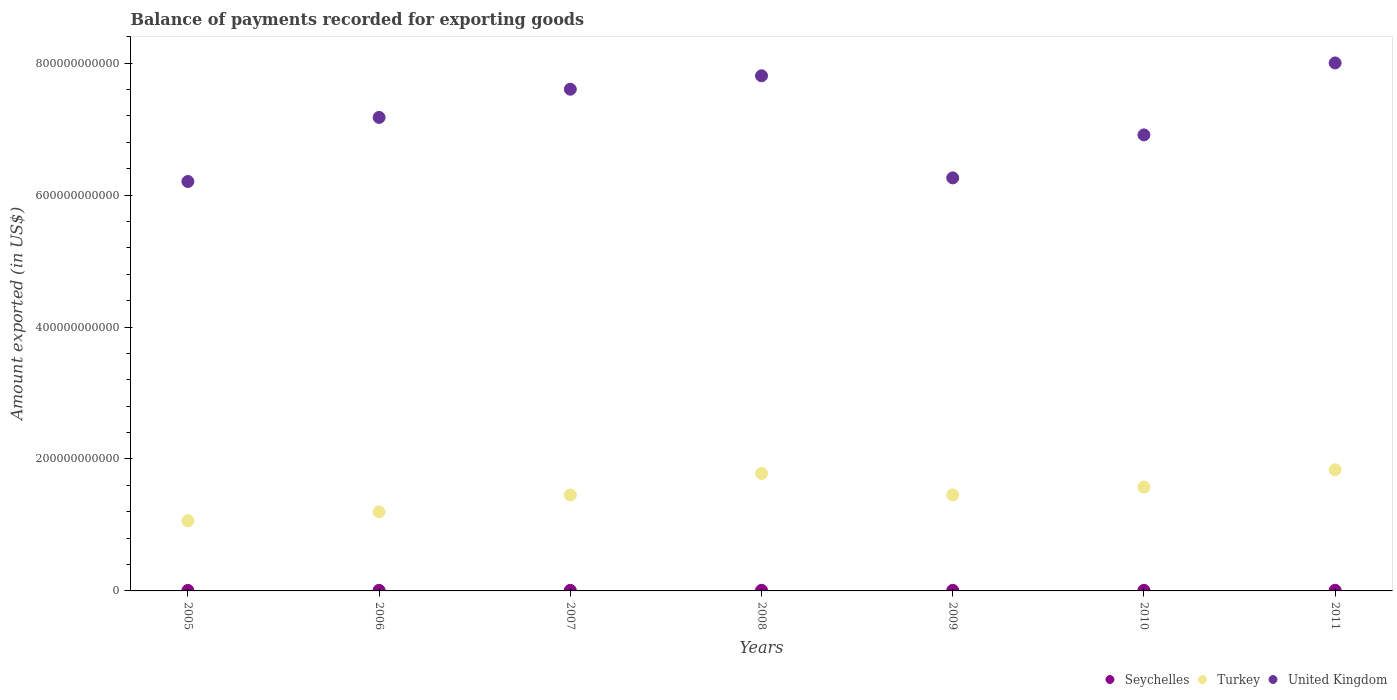Is the number of dotlines equal to the number of legend labels?
Ensure brevity in your answer.  Yes. What is the amount exported in Seychelles in 2011?
Keep it short and to the point. 9.42e+08. Across all years, what is the maximum amount exported in United Kingdom?
Provide a succinct answer. 8.00e+11. Across all years, what is the minimum amount exported in United Kingdom?
Your response must be concise. 6.21e+11. What is the total amount exported in Seychelles in the graph?
Ensure brevity in your answer.  5.96e+09. What is the difference between the amount exported in Turkey in 2005 and that in 2010?
Offer a very short reply. -5.11e+1. What is the difference between the amount exported in United Kingdom in 2009 and the amount exported in Seychelles in 2007?
Your answer should be compact. 6.25e+11. What is the average amount exported in Seychelles per year?
Ensure brevity in your answer.  8.51e+08. In the year 2011, what is the difference between the amount exported in Seychelles and amount exported in Turkey?
Your answer should be very brief. -1.83e+11. In how many years, is the amount exported in Seychelles greater than 760000000000 US$?
Your answer should be compact. 0. What is the ratio of the amount exported in United Kingdom in 2006 to that in 2011?
Offer a very short reply. 0.9. Is the difference between the amount exported in Seychelles in 2006 and 2010 greater than the difference between the amount exported in Turkey in 2006 and 2010?
Offer a terse response. Yes. What is the difference between the highest and the second highest amount exported in United Kingdom?
Give a very brief answer. 1.95e+1. What is the difference between the highest and the lowest amount exported in Seychelles?
Offer a very short reply. 2.23e+08. Is the sum of the amount exported in United Kingdom in 2005 and 2009 greater than the maximum amount exported in Turkey across all years?
Offer a terse response. Yes. Is it the case that in every year, the sum of the amount exported in United Kingdom and amount exported in Seychelles  is greater than the amount exported in Turkey?
Your answer should be very brief. Yes. Is the amount exported in Turkey strictly greater than the amount exported in United Kingdom over the years?
Offer a very short reply. No. How many years are there in the graph?
Make the answer very short. 7. What is the difference between two consecutive major ticks on the Y-axis?
Provide a short and direct response. 2.00e+11. Are the values on the major ticks of Y-axis written in scientific E-notation?
Offer a very short reply. No. Does the graph contain any zero values?
Offer a terse response. No. Does the graph contain grids?
Your answer should be compact. No. How are the legend labels stacked?
Ensure brevity in your answer.  Horizontal. What is the title of the graph?
Offer a terse response. Balance of payments recorded for exporting goods. Does "Arab World" appear as one of the legend labels in the graph?
Your response must be concise. No. What is the label or title of the Y-axis?
Offer a very short reply. Amount exported (in US$). What is the Amount exported (in US$) of Seychelles in 2005?
Make the answer very short. 7.20e+08. What is the Amount exported (in US$) of Turkey in 2005?
Ensure brevity in your answer.  1.06e+11. What is the Amount exported (in US$) in United Kingdom in 2005?
Give a very brief answer. 6.21e+11. What is the Amount exported (in US$) of Seychelles in 2006?
Offer a terse response. 8.50e+08. What is the Amount exported (in US$) in Turkey in 2006?
Provide a short and direct response. 1.20e+11. What is the Amount exported (in US$) in United Kingdom in 2006?
Provide a short and direct response. 7.18e+11. What is the Amount exported (in US$) of Seychelles in 2007?
Give a very brief answer. 8.54e+08. What is the Amount exported (in US$) in Turkey in 2007?
Give a very brief answer. 1.45e+11. What is the Amount exported (in US$) in United Kingdom in 2007?
Make the answer very short. 7.61e+11. What is the Amount exported (in US$) in Seychelles in 2008?
Give a very brief answer. 9.02e+08. What is the Amount exported (in US$) in Turkey in 2008?
Offer a very short reply. 1.78e+11. What is the Amount exported (in US$) in United Kingdom in 2008?
Ensure brevity in your answer.  7.81e+11. What is the Amount exported (in US$) in Seychelles in 2009?
Your response must be concise. 8.50e+08. What is the Amount exported (in US$) in Turkey in 2009?
Your response must be concise. 1.46e+11. What is the Amount exported (in US$) in United Kingdom in 2009?
Offer a very short reply. 6.26e+11. What is the Amount exported (in US$) in Seychelles in 2010?
Your answer should be compact. 8.41e+08. What is the Amount exported (in US$) of Turkey in 2010?
Give a very brief answer. 1.57e+11. What is the Amount exported (in US$) in United Kingdom in 2010?
Keep it short and to the point. 6.91e+11. What is the Amount exported (in US$) in Seychelles in 2011?
Ensure brevity in your answer.  9.42e+08. What is the Amount exported (in US$) in Turkey in 2011?
Keep it short and to the point. 1.84e+11. What is the Amount exported (in US$) in United Kingdom in 2011?
Your answer should be very brief. 8.00e+11. Across all years, what is the maximum Amount exported (in US$) in Seychelles?
Ensure brevity in your answer.  9.42e+08. Across all years, what is the maximum Amount exported (in US$) in Turkey?
Provide a short and direct response. 1.84e+11. Across all years, what is the maximum Amount exported (in US$) of United Kingdom?
Your answer should be compact. 8.00e+11. Across all years, what is the minimum Amount exported (in US$) of Seychelles?
Give a very brief answer. 7.20e+08. Across all years, what is the minimum Amount exported (in US$) in Turkey?
Your answer should be compact. 1.06e+11. Across all years, what is the minimum Amount exported (in US$) of United Kingdom?
Offer a very short reply. 6.21e+11. What is the total Amount exported (in US$) in Seychelles in the graph?
Offer a terse response. 5.96e+09. What is the total Amount exported (in US$) of Turkey in the graph?
Your response must be concise. 1.04e+12. What is the total Amount exported (in US$) in United Kingdom in the graph?
Your answer should be compact. 5.00e+12. What is the difference between the Amount exported (in US$) in Seychelles in 2005 and that in 2006?
Your response must be concise. -1.31e+08. What is the difference between the Amount exported (in US$) of Turkey in 2005 and that in 2006?
Keep it short and to the point. -1.35e+1. What is the difference between the Amount exported (in US$) of United Kingdom in 2005 and that in 2006?
Provide a short and direct response. -9.71e+1. What is the difference between the Amount exported (in US$) in Seychelles in 2005 and that in 2007?
Your answer should be very brief. -1.34e+08. What is the difference between the Amount exported (in US$) of Turkey in 2005 and that in 2007?
Your answer should be compact. -3.91e+1. What is the difference between the Amount exported (in US$) of United Kingdom in 2005 and that in 2007?
Provide a short and direct response. -1.40e+11. What is the difference between the Amount exported (in US$) in Seychelles in 2005 and that in 2008?
Ensure brevity in your answer.  -1.82e+08. What is the difference between the Amount exported (in US$) in Turkey in 2005 and that in 2008?
Your answer should be compact. -7.17e+1. What is the difference between the Amount exported (in US$) of United Kingdom in 2005 and that in 2008?
Provide a short and direct response. -1.60e+11. What is the difference between the Amount exported (in US$) in Seychelles in 2005 and that in 2009?
Your answer should be compact. -1.30e+08. What is the difference between the Amount exported (in US$) in Turkey in 2005 and that in 2009?
Make the answer very short. -3.92e+1. What is the difference between the Amount exported (in US$) in United Kingdom in 2005 and that in 2009?
Offer a terse response. -5.48e+09. What is the difference between the Amount exported (in US$) of Seychelles in 2005 and that in 2010?
Offer a terse response. -1.21e+08. What is the difference between the Amount exported (in US$) of Turkey in 2005 and that in 2010?
Keep it short and to the point. -5.11e+1. What is the difference between the Amount exported (in US$) in United Kingdom in 2005 and that in 2010?
Offer a very short reply. -7.06e+1. What is the difference between the Amount exported (in US$) of Seychelles in 2005 and that in 2011?
Offer a terse response. -2.23e+08. What is the difference between the Amount exported (in US$) of Turkey in 2005 and that in 2011?
Your answer should be compact. -7.73e+1. What is the difference between the Amount exported (in US$) of United Kingdom in 2005 and that in 2011?
Keep it short and to the point. -1.80e+11. What is the difference between the Amount exported (in US$) of Seychelles in 2006 and that in 2007?
Ensure brevity in your answer.  -3.37e+06. What is the difference between the Amount exported (in US$) in Turkey in 2006 and that in 2007?
Your response must be concise. -2.55e+1. What is the difference between the Amount exported (in US$) in United Kingdom in 2006 and that in 2007?
Provide a short and direct response. -4.28e+1. What is the difference between the Amount exported (in US$) in Seychelles in 2006 and that in 2008?
Your answer should be very brief. -5.17e+07. What is the difference between the Amount exported (in US$) in Turkey in 2006 and that in 2008?
Your answer should be compact. -5.82e+1. What is the difference between the Amount exported (in US$) in United Kingdom in 2006 and that in 2008?
Your response must be concise. -6.31e+1. What is the difference between the Amount exported (in US$) of Seychelles in 2006 and that in 2009?
Give a very brief answer. 5.69e+05. What is the difference between the Amount exported (in US$) in Turkey in 2006 and that in 2009?
Offer a very short reply. -2.57e+1. What is the difference between the Amount exported (in US$) in United Kingdom in 2006 and that in 2009?
Provide a short and direct response. 9.16e+1. What is the difference between the Amount exported (in US$) of Seychelles in 2006 and that in 2010?
Make the answer very short. 9.62e+06. What is the difference between the Amount exported (in US$) of Turkey in 2006 and that in 2010?
Keep it short and to the point. -3.76e+1. What is the difference between the Amount exported (in US$) of United Kingdom in 2006 and that in 2010?
Ensure brevity in your answer.  2.65e+1. What is the difference between the Amount exported (in US$) in Seychelles in 2006 and that in 2011?
Provide a short and direct response. -9.21e+07. What is the difference between the Amount exported (in US$) in Turkey in 2006 and that in 2011?
Your response must be concise. -6.38e+1. What is the difference between the Amount exported (in US$) in United Kingdom in 2006 and that in 2011?
Offer a terse response. -8.26e+1. What is the difference between the Amount exported (in US$) of Seychelles in 2007 and that in 2008?
Keep it short and to the point. -4.83e+07. What is the difference between the Amount exported (in US$) of Turkey in 2007 and that in 2008?
Give a very brief answer. -3.26e+1. What is the difference between the Amount exported (in US$) of United Kingdom in 2007 and that in 2008?
Provide a short and direct response. -2.04e+1. What is the difference between the Amount exported (in US$) of Seychelles in 2007 and that in 2009?
Your answer should be compact. 3.94e+06. What is the difference between the Amount exported (in US$) in Turkey in 2007 and that in 2009?
Your answer should be compact. -1.64e+08. What is the difference between the Amount exported (in US$) of United Kingdom in 2007 and that in 2009?
Ensure brevity in your answer.  1.34e+11. What is the difference between the Amount exported (in US$) in Seychelles in 2007 and that in 2010?
Provide a succinct answer. 1.30e+07. What is the difference between the Amount exported (in US$) of Turkey in 2007 and that in 2010?
Your response must be concise. -1.21e+1. What is the difference between the Amount exported (in US$) in United Kingdom in 2007 and that in 2010?
Make the answer very short. 6.93e+1. What is the difference between the Amount exported (in US$) of Seychelles in 2007 and that in 2011?
Provide a succinct answer. -8.87e+07. What is the difference between the Amount exported (in US$) of Turkey in 2007 and that in 2011?
Make the answer very short. -3.83e+1. What is the difference between the Amount exported (in US$) in United Kingdom in 2007 and that in 2011?
Your answer should be compact. -3.98e+1. What is the difference between the Amount exported (in US$) of Seychelles in 2008 and that in 2009?
Your response must be concise. 5.23e+07. What is the difference between the Amount exported (in US$) in Turkey in 2008 and that in 2009?
Your answer should be very brief. 3.25e+1. What is the difference between the Amount exported (in US$) in United Kingdom in 2008 and that in 2009?
Offer a terse response. 1.55e+11. What is the difference between the Amount exported (in US$) of Seychelles in 2008 and that in 2010?
Make the answer very short. 6.13e+07. What is the difference between the Amount exported (in US$) of Turkey in 2008 and that in 2010?
Provide a short and direct response. 2.06e+1. What is the difference between the Amount exported (in US$) of United Kingdom in 2008 and that in 2010?
Your answer should be compact. 8.96e+1. What is the difference between the Amount exported (in US$) of Seychelles in 2008 and that in 2011?
Offer a very short reply. -4.04e+07. What is the difference between the Amount exported (in US$) in Turkey in 2008 and that in 2011?
Offer a very short reply. -5.64e+09. What is the difference between the Amount exported (in US$) in United Kingdom in 2008 and that in 2011?
Your answer should be very brief. -1.95e+1. What is the difference between the Amount exported (in US$) of Seychelles in 2009 and that in 2010?
Make the answer very short. 9.05e+06. What is the difference between the Amount exported (in US$) of Turkey in 2009 and that in 2010?
Keep it short and to the point. -1.19e+1. What is the difference between the Amount exported (in US$) in United Kingdom in 2009 and that in 2010?
Make the answer very short. -6.51e+1. What is the difference between the Amount exported (in US$) in Seychelles in 2009 and that in 2011?
Make the answer very short. -9.27e+07. What is the difference between the Amount exported (in US$) in Turkey in 2009 and that in 2011?
Make the answer very short. -3.81e+1. What is the difference between the Amount exported (in US$) of United Kingdom in 2009 and that in 2011?
Your answer should be compact. -1.74e+11. What is the difference between the Amount exported (in US$) in Seychelles in 2010 and that in 2011?
Provide a short and direct response. -1.02e+08. What is the difference between the Amount exported (in US$) of Turkey in 2010 and that in 2011?
Offer a terse response. -2.62e+1. What is the difference between the Amount exported (in US$) in United Kingdom in 2010 and that in 2011?
Offer a terse response. -1.09e+11. What is the difference between the Amount exported (in US$) of Seychelles in 2005 and the Amount exported (in US$) of Turkey in 2006?
Keep it short and to the point. -1.19e+11. What is the difference between the Amount exported (in US$) of Seychelles in 2005 and the Amount exported (in US$) of United Kingdom in 2006?
Offer a terse response. -7.17e+11. What is the difference between the Amount exported (in US$) of Turkey in 2005 and the Amount exported (in US$) of United Kingdom in 2006?
Your answer should be compact. -6.11e+11. What is the difference between the Amount exported (in US$) in Seychelles in 2005 and the Amount exported (in US$) in Turkey in 2007?
Make the answer very short. -1.45e+11. What is the difference between the Amount exported (in US$) in Seychelles in 2005 and the Amount exported (in US$) in United Kingdom in 2007?
Keep it short and to the point. -7.60e+11. What is the difference between the Amount exported (in US$) of Turkey in 2005 and the Amount exported (in US$) of United Kingdom in 2007?
Offer a very short reply. -6.54e+11. What is the difference between the Amount exported (in US$) in Seychelles in 2005 and the Amount exported (in US$) in Turkey in 2008?
Offer a very short reply. -1.77e+11. What is the difference between the Amount exported (in US$) in Seychelles in 2005 and the Amount exported (in US$) in United Kingdom in 2008?
Your answer should be compact. -7.80e+11. What is the difference between the Amount exported (in US$) of Turkey in 2005 and the Amount exported (in US$) of United Kingdom in 2008?
Make the answer very short. -6.75e+11. What is the difference between the Amount exported (in US$) in Seychelles in 2005 and the Amount exported (in US$) in Turkey in 2009?
Offer a terse response. -1.45e+11. What is the difference between the Amount exported (in US$) in Seychelles in 2005 and the Amount exported (in US$) in United Kingdom in 2009?
Make the answer very short. -6.25e+11. What is the difference between the Amount exported (in US$) in Turkey in 2005 and the Amount exported (in US$) in United Kingdom in 2009?
Ensure brevity in your answer.  -5.20e+11. What is the difference between the Amount exported (in US$) of Seychelles in 2005 and the Amount exported (in US$) of Turkey in 2010?
Your answer should be very brief. -1.57e+11. What is the difference between the Amount exported (in US$) in Seychelles in 2005 and the Amount exported (in US$) in United Kingdom in 2010?
Make the answer very short. -6.91e+11. What is the difference between the Amount exported (in US$) in Turkey in 2005 and the Amount exported (in US$) in United Kingdom in 2010?
Your answer should be compact. -5.85e+11. What is the difference between the Amount exported (in US$) in Seychelles in 2005 and the Amount exported (in US$) in Turkey in 2011?
Provide a short and direct response. -1.83e+11. What is the difference between the Amount exported (in US$) of Seychelles in 2005 and the Amount exported (in US$) of United Kingdom in 2011?
Provide a succinct answer. -8.00e+11. What is the difference between the Amount exported (in US$) in Turkey in 2005 and the Amount exported (in US$) in United Kingdom in 2011?
Your response must be concise. -6.94e+11. What is the difference between the Amount exported (in US$) in Seychelles in 2006 and the Amount exported (in US$) in Turkey in 2007?
Offer a terse response. -1.45e+11. What is the difference between the Amount exported (in US$) in Seychelles in 2006 and the Amount exported (in US$) in United Kingdom in 2007?
Your response must be concise. -7.60e+11. What is the difference between the Amount exported (in US$) of Turkey in 2006 and the Amount exported (in US$) of United Kingdom in 2007?
Offer a terse response. -6.41e+11. What is the difference between the Amount exported (in US$) of Seychelles in 2006 and the Amount exported (in US$) of Turkey in 2008?
Make the answer very short. -1.77e+11. What is the difference between the Amount exported (in US$) in Seychelles in 2006 and the Amount exported (in US$) in United Kingdom in 2008?
Make the answer very short. -7.80e+11. What is the difference between the Amount exported (in US$) in Turkey in 2006 and the Amount exported (in US$) in United Kingdom in 2008?
Provide a short and direct response. -6.61e+11. What is the difference between the Amount exported (in US$) of Seychelles in 2006 and the Amount exported (in US$) of Turkey in 2009?
Provide a succinct answer. -1.45e+11. What is the difference between the Amount exported (in US$) in Seychelles in 2006 and the Amount exported (in US$) in United Kingdom in 2009?
Offer a terse response. -6.25e+11. What is the difference between the Amount exported (in US$) of Turkey in 2006 and the Amount exported (in US$) of United Kingdom in 2009?
Your response must be concise. -5.06e+11. What is the difference between the Amount exported (in US$) in Seychelles in 2006 and the Amount exported (in US$) in Turkey in 2010?
Make the answer very short. -1.57e+11. What is the difference between the Amount exported (in US$) of Seychelles in 2006 and the Amount exported (in US$) of United Kingdom in 2010?
Provide a short and direct response. -6.90e+11. What is the difference between the Amount exported (in US$) of Turkey in 2006 and the Amount exported (in US$) of United Kingdom in 2010?
Offer a terse response. -5.71e+11. What is the difference between the Amount exported (in US$) of Seychelles in 2006 and the Amount exported (in US$) of Turkey in 2011?
Keep it short and to the point. -1.83e+11. What is the difference between the Amount exported (in US$) of Seychelles in 2006 and the Amount exported (in US$) of United Kingdom in 2011?
Ensure brevity in your answer.  -7.99e+11. What is the difference between the Amount exported (in US$) in Turkey in 2006 and the Amount exported (in US$) in United Kingdom in 2011?
Your response must be concise. -6.80e+11. What is the difference between the Amount exported (in US$) in Seychelles in 2007 and the Amount exported (in US$) in Turkey in 2008?
Your answer should be compact. -1.77e+11. What is the difference between the Amount exported (in US$) in Seychelles in 2007 and the Amount exported (in US$) in United Kingdom in 2008?
Keep it short and to the point. -7.80e+11. What is the difference between the Amount exported (in US$) in Turkey in 2007 and the Amount exported (in US$) in United Kingdom in 2008?
Your answer should be very brief. -6.36e+11. What is the difference between the Amount exported (in US$) of Seychelles in 2007 and the Amount exported (in US$) of Turkey in 2009?
Keep it short and to the point. -1.45e+11. What is the difference between the Amount exported (in US$) in Seychelles in 2007 and the Amount exported (in US$) in United Kingdom in 2009?
Ensure brevity in your answer.  -6.25e+11. What is the difference between the Amount exported (in US$) of Turkey in 2007 and the Amount exported (in US$) of United Kingdom in 2009?
Give a very brief answer. -4.81e+11. What is the difference between the Amount exported (in US$) of Seychelles in 2007 and the Amount exported (in US$) of Turkey in 2010?
Your answer should be very brief. -1.57e+11. What is the difference between the Amount exported (in US$) in Seychelles in 2007 and the Amount exported (in US$) in United Kingdom in 2010?
Make the answer very short. -6.90e+11. What is the difference between the Amount exported (in US$) of Turkey in 2007 and the Amount exported (in US$) of United Kingdom in 2010?
Your answer should be very brief. -5.46e+11. What is the difference between the Amount exported (in US$) in Seychelles in 2007 and the Amount exported (in US$) in Turkey in 2011?
Provide a short and direct response. -1.83e+11. What is the difference between the Amount exported (in US$) in Seychelles in 2007 and the Amount exported (in US$) in United Kingdom in 2011?
Provide a succinct answer. -7.99e+11. What is the difference between the Amount exported (in US$) in Turkey in 2007 and the Amount exported (in US$) in United Kingdom in 2011?
Provide a succinct answer. -6.55e+11. What is the difference between the Amount exported (in US$) in Seychelles in 2008 and the Amount exported (in US$) in Turkey in 2009?
Provide a succinct answer. -1.45e+11. What is the difference between the Amount exported (in US$) in Seychelles in 2008 and the Amount exported (in US$) in United Kingdom in 2009?
Your response must be concise. -6.25e+11. What is the difference between the Amount exported (in US$) of Turkey in 2008 and the Amount exported (in US$) of United Kingdom in 2009?
Make the answer very short. -4.48e+11. What is the difference between the Amount exported (in US$) of Seychelles in 2008 and the Amount exported (in US$) of Turkey in 2010?
Keep it short and to the point. -1.57e+11. What is the difference between the Amount exported (in US$) of Seychelles in 2008 and the Amount exported (in US$) of United Kingdom in 2010?
Make the answer very short. -6.90e+11. What is the difference between the Amount exported (in US$) of Turkey in 2008 and the Amount exported (in US$) of United Kingdom in 2010?
Make the answer very short. -5.13e+11. What is the difference between the Amount exported (in US$) in Seychelles in 2008 and the Amount exported (in US$) in Turkey in 2011?
Offer a very short reply. -1.83e+11. What is the difference between the Amount exported (in US$) of Seychelles in 2008 and the Amount exported (in US$) of United Kingdom in 2011?
Offer a terse response. -7.99e+11. What is the difference between the Amount exported (in US$) in Turkey in 2008 and the Amount exported (in US$) in United Kingdom in 2011?
Your answer should be compact. -6.22e+11. What is the difference between the Amount exported (in US$) in Seychelles in 2009 and the Amount exported (in US$) in Turkey in 2010?
Make the answer very short. -1.57e+11. What is the difference between the Amount exported (in US$) of Seychelles in 2009 and the Amount exported (in US$) of United Kingdom in 2010?
Give a very brief answer. -6.90e+11. What is the difference between the Amount exported (in US$) of Turkey in 2009 and the Amount exported (in US$) of United Kingdom in 2010?
Provide a short and direct response. -5.46e+11. What is the difference between the Amount exported (in US$) in Seychelles in 2009 and the Amount exported (in US$) in Turkey in 2011?
Offer a terse response. -1.83e+11. What is the difference between the Amount exported (in US$) in Seychelles in 2009 and the Amount exported (in US$) in United Kingdom in 2011?
Your answer should be very brief. -7.99e+11. What is the difference between the Amount exported (in US$) of Turkey in 2009 and the Amount exported (in US$) of United Kingdom in 2011?
Ensure brevity in your answer.  -6.55e+11. What is the difference between the Amount exported (in US$) in Seychelles in 2010 and the Amount exported (in US$) in Turkey in 2011?
Offer a very short reply. -1.83e+11. What is the difference between the Amount exported (in US$) of Seychelles in 2010 and the Amount exported (in US$) of United Kingdom in 2011?
Your response must be concise. -8.00e+11. What is the difference between the Amount exported (in US$) in Turkey in 2010 and the Amount exported (in US$) in United Kingdom in 2011?
Provide a succinct answer. -6.43e+11. What is the average Amount exported (in US$) in Seychelles per year?
Make the answer very short. 8.51e+08. What is the average Amount exported (in US$) of Turkey per year?
Give a very brief answer. 1.48e+11. What is the average Amount exported (in US$) of United Kingdom per year?
Your answer should be very brief. 7.14e+11. In the year 2005, what is the difference between the Amount exported (in US$) in Seychelles and Amount exported (in US$) in Turkey?
Keep it short and to the point. -1.06e+11. In the year 2005, what is the difference between the Amount exported (in US$) in Seychelles and Amount exported (in US$) in United Kingdom?
Ensure brevity in your answer.  -6.20e+11. In the year 2005, what is the difference between the Amount exported (in US$) of Turkey and Amount exported (in US$) of United Kingdom?
Keep it short and to the point. -5.14e+11. In the year 2006, what is the difference between the Amount exported (in US$) in Seychelles and Amount exported (in US$) in Turkey?
Your answer should be very brief. -1.19e+11. In the year 2006, what is the difference between the Amount exported (in US$) in Seychelles and Amount exported (in US$) in United Kingdom?
Offer a very short reply. -7.17e+11. In the year 2006, what is the difference between the Amount exported (in US$) of Turkey and Amount exported (in US$) of United Kingdom?
Your answer should be very brief. -5.98e+11. In the year 2007, what is the difference between the Amount exported (in US$) of Seychelles and Amount exported (in US$) of Turkey?
Provide a short and direct response. -1.45e+11. In the year 2007, what is the difference between the Amount exported (in US$) in Seychelles and Amount exported (in US$) in United Kingdom?
Your answer should be compact. -7.60e+11. In the year 2007, what is the difference between the Amount exported (in US$) in Turkey and Amount exported (in US$) in United Kingdom?
Offer a very short reply. -6.15e+11. In the year 2008, what is the difference between the Amount exported (in US$) in Seychelles and Amount exported (in US$) in Turkey?
Make the answer very short. -1.77e+11. In the year 2008, what is the difference between the Amount exported (in US$) in Seychelles and Amount exported (in US$) in United Kingdom?
Offer a terse response. -7.80e+11. In the year 2008, what is the difference between the Amount exported (in US$) of Turkey and Amount exported (in US$) of United Kingdom?
Give a very brief answer. -6.03e+11. In the year 2009, what is the difference between the Amount exported (in US$) in Seychelles and Amount exported (in US$) in Turkey?
Make the answer very short. -1.45e+11. In the year 2009, what is the difference between the Amount exported (in US$) of Seychelles and Amount exported (in US$) of United Kingdom?
Provide a short and direct response. -6.25e+11. In the year 2009, what is the difference between the Amount exported (in US$) of Turkey and Amount exported (in US$) of United Kingdom?
Ensure brevity in your answer.  -4.81e+11. In the year 2010, what is the difference between the Amount exported (in US$) in Seychelles and Amount exported (in US$) in Turkey?
Make the answer very short. -1.57e+11. In the year 2010, what is the difference between the Amount exported (in US$) of Seychelles and Amount exported (in US$) of United Kingdom?
Provide a succinct answer. -6.90e+11. In the year 2010, what is the difference between the Amount exported (in US$) in Turkey and Amount exported (in US$) in United Kingdom?
Offer a terse response. -5.34e+11. In the year 2011, what is the difference between the Amount exported (in US$) in Seychelles and Amount exported (in US$) in Turkey?
Offer a terse response. -1.83e+11. In the year 2011, what is the difference between the Amount exported (in US$) of Seychelles and Amount exported (in US$) of United Kingdom?
Keep it short and to the point. -7.99e+11. In the year 2011, what is the difference between the Amount exported (in US$) in Turkey and Amount exported (in US$) in United Kingdom?
Give a very brief answer. -6.17e+11. What is the ratio of the Amount exported (in US$) of Seychelles in 2005 to that in 2006?
Offer a terse response. 0.85. What is the ratio of the Amount exported (in US$) of Turkey in 2005 to that in 2006?
Your response must be concise. 0.89. What is the ratio of the Amount exported (in US$) of United Kingdom in 2005 to that in 2006?
Provide a succinct answer. 0.86. What is the ratio of the Amount exported (in US$) of Seychelles in 2005 to that in 2007?
Give a very brief answer. 0.84. What is the ratio of the Amount exported (in US$) of Turkey in 2005 to that in 2007?
Provide a short and direct response. 0.73. What is the ratio of the Amount exported (in US$) in United Kingdom in 2005 to that in 2007?
Your answer should be compact. 0.82. What is the ratio of the Amount exported (in US$) in Seychelles in 2005 to that in 2008?
Your response must be concise. 0.8. What is the ratio of the Amount exported (in US$) of Turkey in 2005 to that in 2008?
Offer a very short reply. 0.6. What is the ratio of the Amount exported (in US$) of United Kingdom in 2005 to that in 2008?
Keep it short and to the point. 0.79. What is the ratio of the Amount exported (in US$) in Seychelles in 2005 to that in 2009?
Your answer should be very brief. 0.85. What is the ratio of the Amount exported (in US$) of Turkey in 2005 to that in 2009?
Offer a very short reply. 0.73. What is the ratio of the Amount exported (in US$) in Seychelles in 2005 to that in 2010?
Keep it short and to the point. 0.86. What is the ratio of the Amount exported (in US$) of Turkey in 2005 to that in 2010?
Your response must be concise. 0.68. What is the ratio of the Amount exported (in US$) of United Kingdom in 2005 to that in 2010?
Keep it short and to the point. 0.9. What is the ratio of the Amount exported (in US$) in Seychelles in 2005 to that in 2011?
Offer a very short reply. 0.76. What is the ratio of the Amount exported (in US$) in Turkey in 2005 to that in 2011?
Provide a succinct answer. 0.58. What is the ratio of the Amount exported (in US$) in United Kingdom in 2005 to that in 2011?
Keep it short and to the point. 0.78. What is the ratio of the Amount exported (in US$) of Turkey in 2006 to that in 2007?
Keep it short and to the point. 0.82. What is the ratio of the Amount exported (in US$) in United Kingdom in 2006 to that in 2007?
Make the answer very short. 0.94. What is the ratio of the Amount exported (in US$) in Seychelles in 2006 to that in 2008?
Give a very brief answer. 0.94. What is the ratio of the Amount exported (in US$) in Turkey in 2006 to that in 2008?
Ensure brevity in your answer.  0.67. What is the ratio of the Amount exported (in US$) of United Kingdom in 2006 to that in 2008?
Your answer should be very brief. 0.92. What is the ratio of the Amount exported (in US$) in Seychelles in 2006 to that in 2009?
Keep it short and to the point. 1. What is the ratio of the Amount exported (in US$) in Turkey in 2006 to that in 2009?
Ensure brevity in your answer.  0.82. What is the ratio of the Amount exported (in US$) in United Kingdom in 2006 to that in 2009?
Ensure brevity in your answer.  1.15. What is the ratio of the Amount exported (in US$) in Seychelles in 2006 to that in 2010?
Offer a terse response. 1.01. What is the ratio of the Amount exported (in US$) in Turkey in 2006 to that in 2010?
Offer a terse response. 0.76. What is the ratio of the Amount exported (in US$) of United Kingdom in 2006 to that in 2010?
Offer a very short reply. 1.04. What is the ratio of the Amount exported (in US$) in Seychelles in 2006 to that in 2011?
Your response must be concise. 0.9. What is the ratio of the Amount exported (in US$) of Turkey in 2006 to that in 2011?
Ensure brevity in your answer.  0.65. What is the ratio of the Amount exported (in US$) in United Kingdom in 2006 to that in 2011?
Provide a succinct answer. 0.9. What is the ratio of the Amount exported (in US$) in Seychelles in 2007 to that in 2008?
Make the answer very short. 0.95. What is the ratio of the Amount exported (in US$) in Turkey in 2007 to that in 2008?
Offer a terse response. 0.82. What is the ratio of the Amount exported (in US$) of United Kingdom in 2007 to that in 2008?
Offer a very short reply. 0.97. What is the ratio of the Amount exported (in US$) of United Kingdom in 2007 to that in 2009?
Your response must be concise. 1.21. What is the ratio of the Amount exported (in US$) of Seychelles in 2007 to that in 2010?
Keep it short and to the point. 1.02. What is the ratio of the Amount exported (in US$) of Turkey in 2007 to that in 2010?
Your answer should be compact. 0.92. What is the ratio of the Amount exported (in US$) of United Kingdom in 2007 to that in 2010?
Offer a terse response. 1.1. What is the ratio of the Amount exported (in US$) of Seychelles in 2007 to that in 2011?
Ensure brevity in your answer.  0.91. What is the ratio of the Amount exported (in US$) in Turkey in 2007 to that in 2011?
Your response must be concise. 0.79. What is the ratio of the Amount exported (in US$) of United Kingdom in 2007 to that in 2011?
Keep it short and to the point. 0.95. What is the ratio of the Amount exported (in US$) in Seychelles in 2008 to that in 2009?
Your response must be concise. 1.06. What is the ratio of the Amount exported (in US$) in Turkey in 2008 to that in 2009?
Give a very brief answer. 1.22. What is the ratio of the Amount exported (in US$) of United Kingdom in 2008 to that in 2009?
Offer a very short reply. 1.25. What is the ratio of the Amount exported (in US$) of Seychelles in 2008 to that in 2010?
Your answer should be very brief. 1.07. What is the ratio of the Amount exported (in US$) in Turkey in 2008 to that in 2010?
Your answer should be very brief. 1.13. What is the ratio of the Amount exported (in US$) of United Kingdom in 2008 to that in 2010?
Offer a very short reply. 1.13. What is the ratio of the Amount exported (in US$) in Seychelles in 2008 to that in 2011?
Keep it short and to the point. 0.96. What is the ratio of the Amount exported (in US$) of Turkey in 2008 to that in 2011?
Provide a short and direct response. 0.97. What is the ratio of the Amount exported (in US$) of United Kingdom in 2008 to that in 2011?
Offer a terse response. 0.98. What is the ratio of the Amount exported (in US$) in Seychelles in 2009 to that in 2010?
Provide a succinct answer. 1.01. What is the ratio of the Amount exported (in US$) of Turkey in 2009 to that in 2010?
Keep it short and to the point. 0.92. What is the ratio of the Amount exported (in US$) in United Kingdom in 2009 to that in 2010?
Your answer should be very brief. 0.91. What is the ratio of the Amount exported (in US$) in Seychelles in 2009 to that in 2011?
Provide a short and direct response. 0.9. What is the ratio of the Amount exported (in US$) of Turkey in 2009 to that in 2011?
Make the answer very short. 0.79. What is the ratio of the Amount exported (in US$) in United Kingdom in 2009 to that in 2011?
Offer a terse response. 0.78. What is the ratio of the Amount exported (in US$) in Seychelles in 2010 to that in 2011?
Offer a very short reply. 0.89. What is the ratio of the Amount exported (in US$) in Turkey in 2010 to that in 2011?
Make the answer very short. 0.86. What is the ratio of the Amount exported (in US$) in United Kingdom in 2010 to that in 2011?
Provide a short and direct response. 0.86. What is the difference between the highest and the second highest Amount exported (in US$) in Seychelles?
Make the answer very short. 4.04e+07. What is the difference between the highest and the second highest Amount exported (in US$) of Turkey?
Give a very brief answer. 5.64e+09. What is the difference between the highest and the second highest Amount exported (in US$) of United Kingdom?
Make the answer very short. 1.95e+1. What is the difference between the highest and the lowest Amount exported (in US$) in Seychelles?
Offer a very short reply. 2.23e+08. What is the difference between the highest and the lowest Amount exported (in US$) of Turkey?
Give a very brief answer. 7.73e+1. What is the difference between the highest and the lowest Amount exported (in US$) of United Kingdom?
Your answer should be very brief. 1.80e+11. 